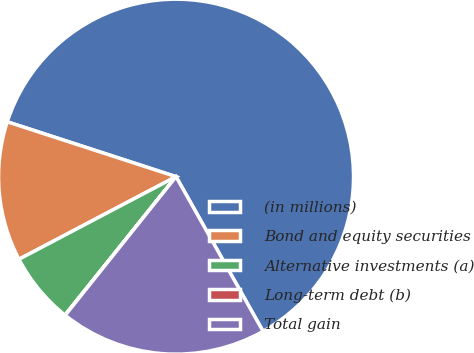Convert chart to OTSL. <chart><loc_0><loc_0><loc_500><loc_500><pie_chart><fcel>(in millions)<fcel>Bond and equity securities<fcel>Alternative investments (a)<fcel>Long-term debt (b)<fcel>Total gain<nl><fcel>61.84%<fcel>12.71%<fcel>6.53%<fcel>0.03%<fcel>18.89%<nl></chart> 